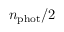Convert formula to latex. <formula><loc_0><loc_0><loc_500><loc_500>n _ { p h o t } / 2</formula> 